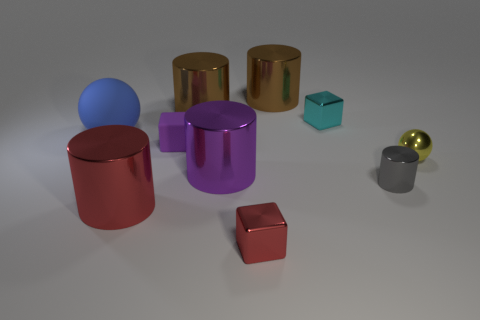What number of other things are made of the same material as the gray object?
Provide a short and direct response. 7. Are there the same number of small purple cubes that are in front of the red cube and purple cubes?
Your response must be concise. No. Is the color of the metal sphere the same as the tiny metal block that is in front of the big blue rubber ball?
Keep it short and to the point. No. The object that is on the left side of the purple block and to the right of the large blue rubber thing is what color?
Make the answer very short. Red. There is a sphere that is on the right side of the blue rubber object; what number of large objects are left of it?
Your answer should be very brief. 5. Is there a gray thing that has the same shape as the purple shiny thing?
Ensure brevity in your answer.  Yes. Does the big brown metal object right of the red cube have the same shape as the metal thing that is to the left of the tiny purple rubber block?
Give a very brief answer. Yes. What number of things are big metallic cylinders or rubber objects?
Keep it short and to the point. 6. What is the size of the cyan metal object that is the same shape as the small purple matte thing?
Give a very brief answer. Small. Is the number of objects in front of the big red thing greater than the number of small green shiny cubes?
Provide a succinct answer. Yes. 